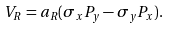Convert formula to latex. <formula><loc_0><loc_0><loc_500><loc_500>V _ { R } = a _ { R } ( \sigma _ { x } P _ { y } - \sigma _ { y } P _ { x } ) .</formula> 